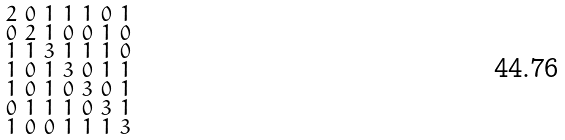<formula> <loc_0><loc_0><loc_500><loc_500>\begin{smallmatrix} 2 & 0 & 1 & 1 & 1 & 0 & 1 \\ 0 & 2 & 1 & 0 & 0 & 1 & 0 \\ 1 & 1 & 3 & 1 & 1 & 1 & 0 \\ 1 & 0 & 1 & 3 & 0 & 1 & 1 \\ 1 & 0 & 1 & 0 & 3 & 0 & 1 \\ 0 & 1 & 1 & 1 & 0 & 3 & 1 \\ 1 & 0 & 0 & 1 & 1 & 1 & 3 \end{smallmatrix}</formula> 